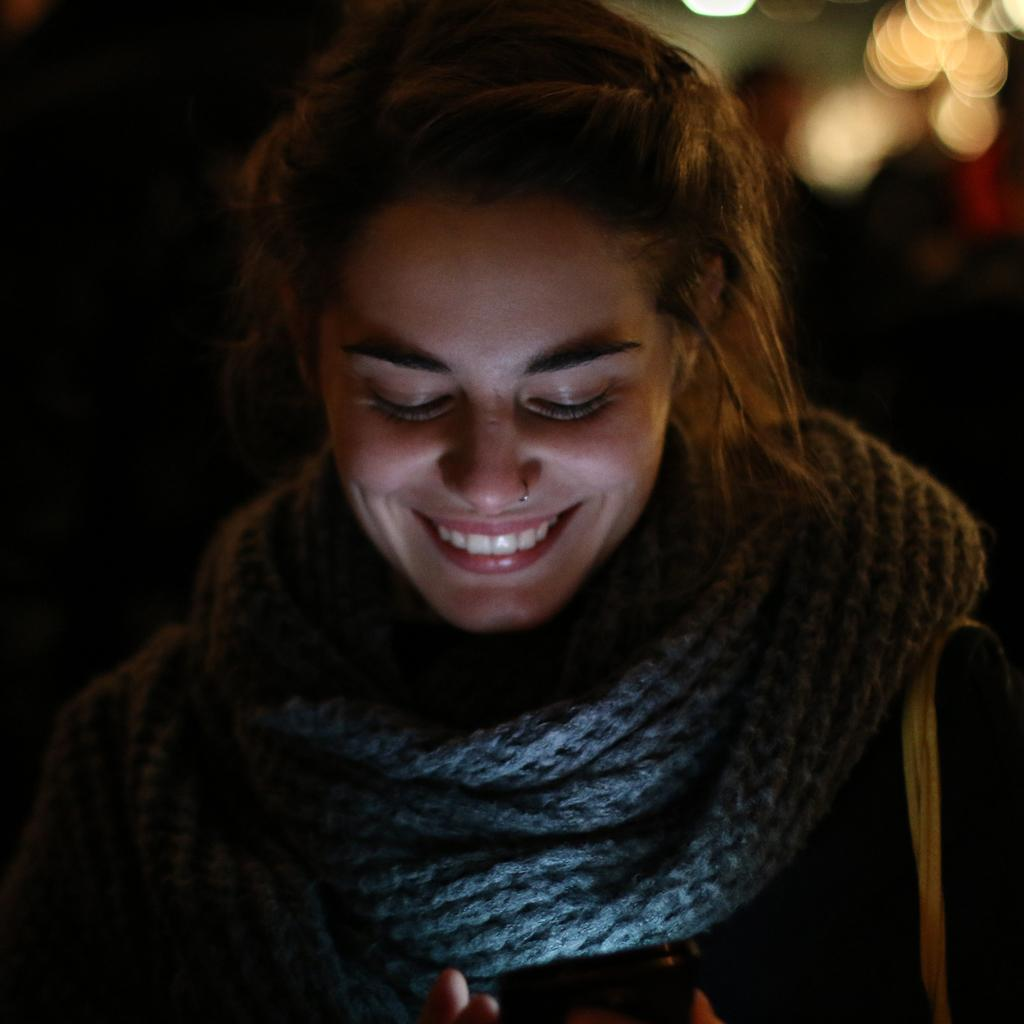Who is present in the image? There is a woman in the image. What is the woman's facial expression? The woman is smiling. What accessory is the woman wearing? The woman is wearing a scarf. What can be seen in the background of the image? There are lights visible in the background of the image. What type of heat does the woman generate in the image? The image does not depict any heat being generated by the woman. 